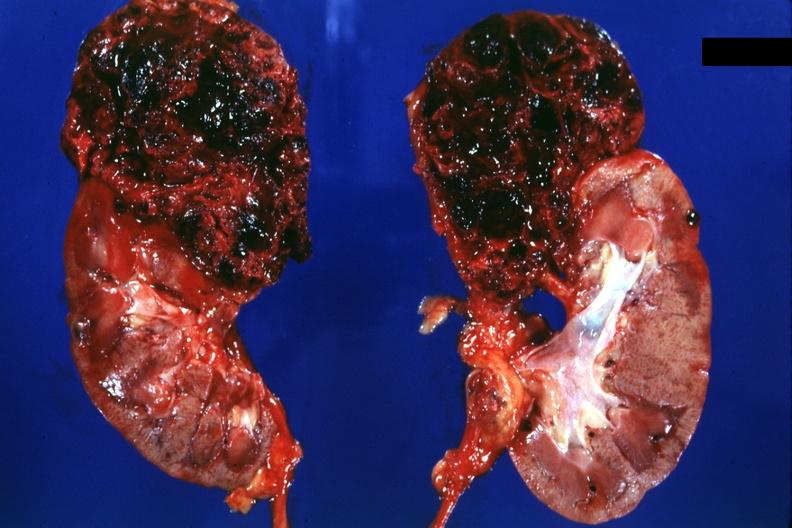s hematologic present?
Answer the question using a single word or phrase. No 